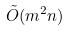<formula> <loc_0><loc_0><loc_500><loc_500>\tilde { O } ( m ^ { 2 } n )</formula> 